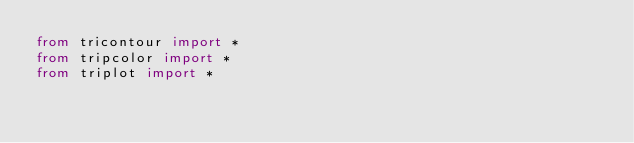Convert code to text. <code><loc_0><loc_0><loc_500><loc_500><_Python_>from tricontour import *
from tripcolor import *
from triplot import *
</code> 